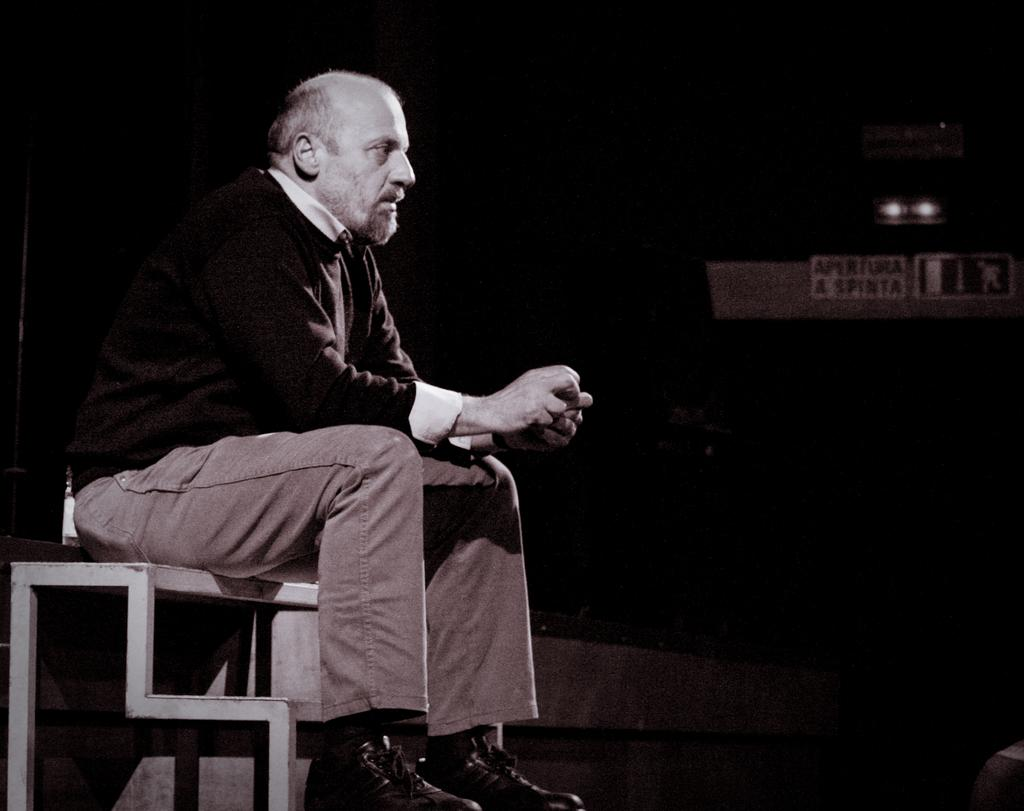Who or what is present in the image? There is a person in the image. What is the person doing in the image? The person is sitting on a table. What type of stew is being served on the table in the image? There is no stew present in the image; it only shows a person sitting on a table. 